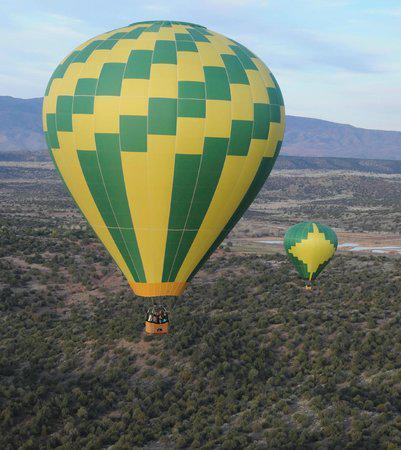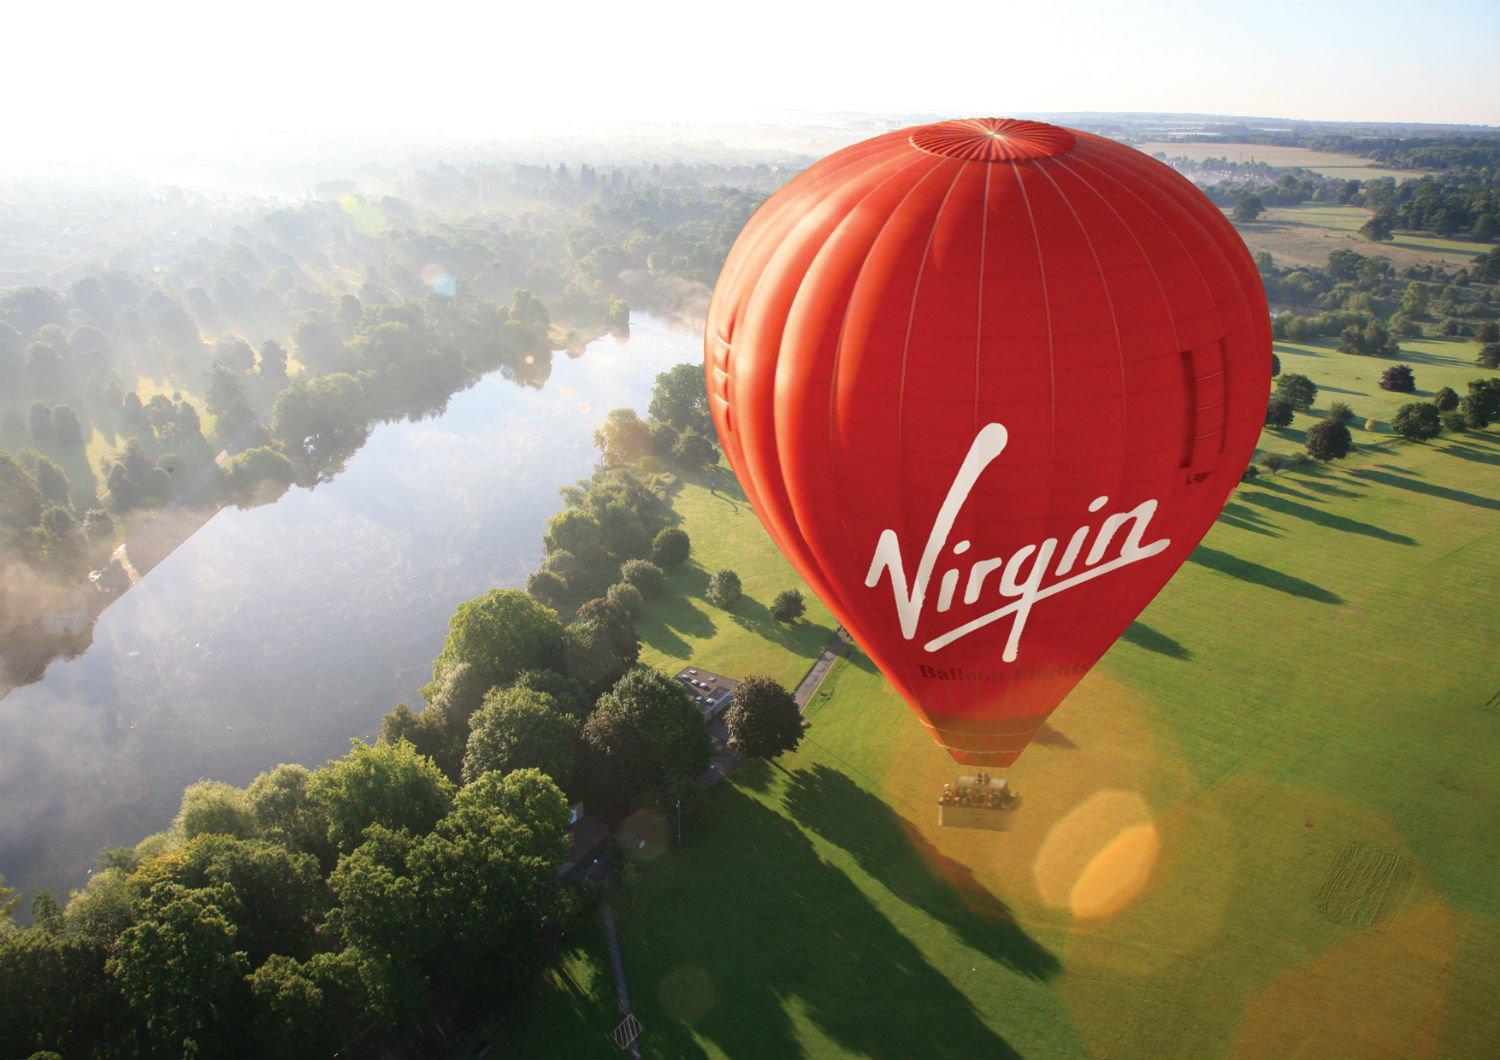The first image is the image on the left, the second image is the image on the right. Examine the images to the left and right. Is the description "There is at least one green and yellow balloon in the image on the left." accurate? Answer yes or no. Yes. 